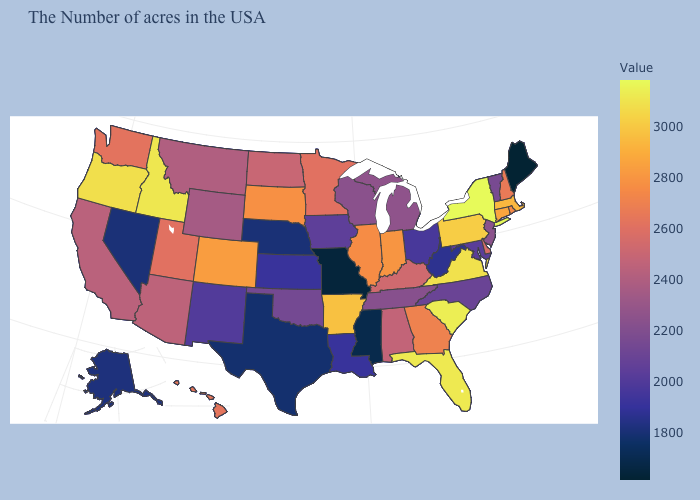Which states hav the highest value in the West?
Answer briefly. Idaho. Among the states that border Mississippi , which have the lowest value?
Concise answer only. Louisiana. Among the states that border Illinois , which have the highest value?
Be succinct. Indiana. Does Iowa have a lower value than Nevada?
Keep it brief. No. Among the states that border Wisconsin , which have the highest value?
Keep it brief. Illinois. Among the states that border Minnesota , does Wisconsin have the highest value?
Keep it brief. No. Does New York have the highest value in the USA?
Be succinct. Yes. Does Illinois have the lowest value in the USA?
Answer briefly. No. 